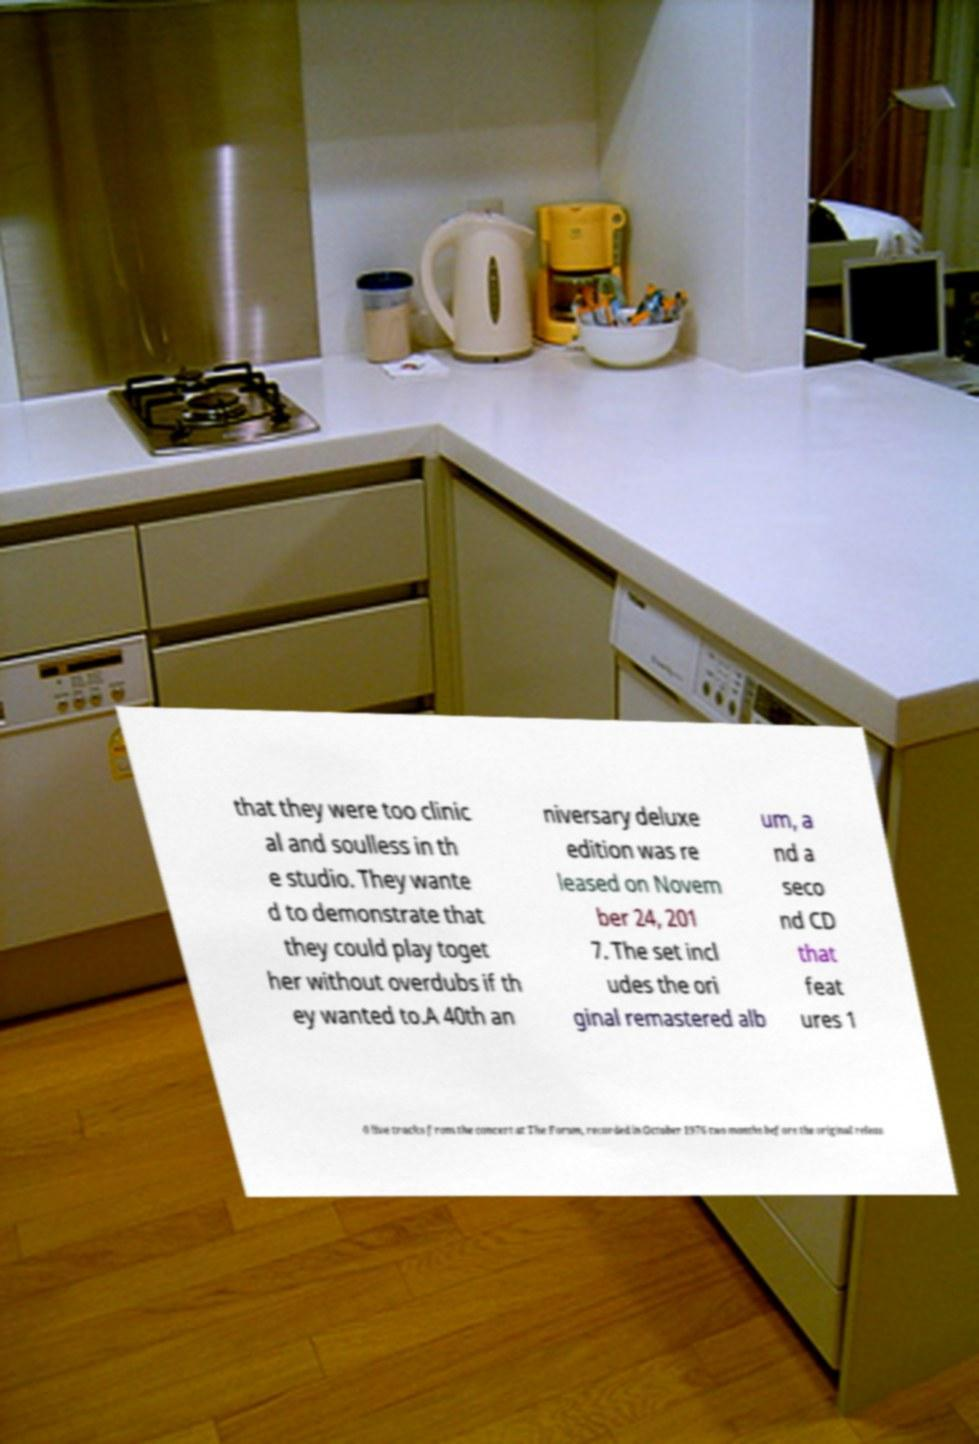Please read and relay the text visible in this image. What does it say? that they were too clinic al and soulless in th e studio. They wante d to demonstrate that they could play toget her without overdubs if th ey wanted to.A 40th an niversary deluxe edition was re leased on Novem ber 24, 201 7. The set incl udes the ori ginal remastered alb um, a nd a seco nd CD that feat ures 1 0 live tracks from the concert at The Forum, recorded in October 1976 two months before the original releas 